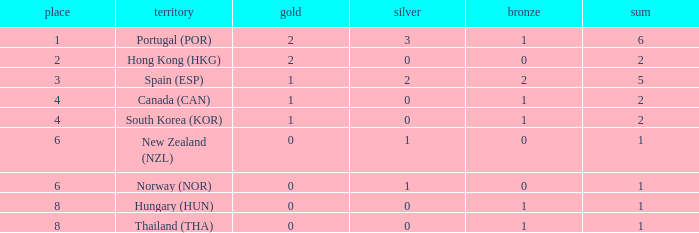What is the lowest Total containing a Bronze of 0 and Rank smaller than 2? None. 